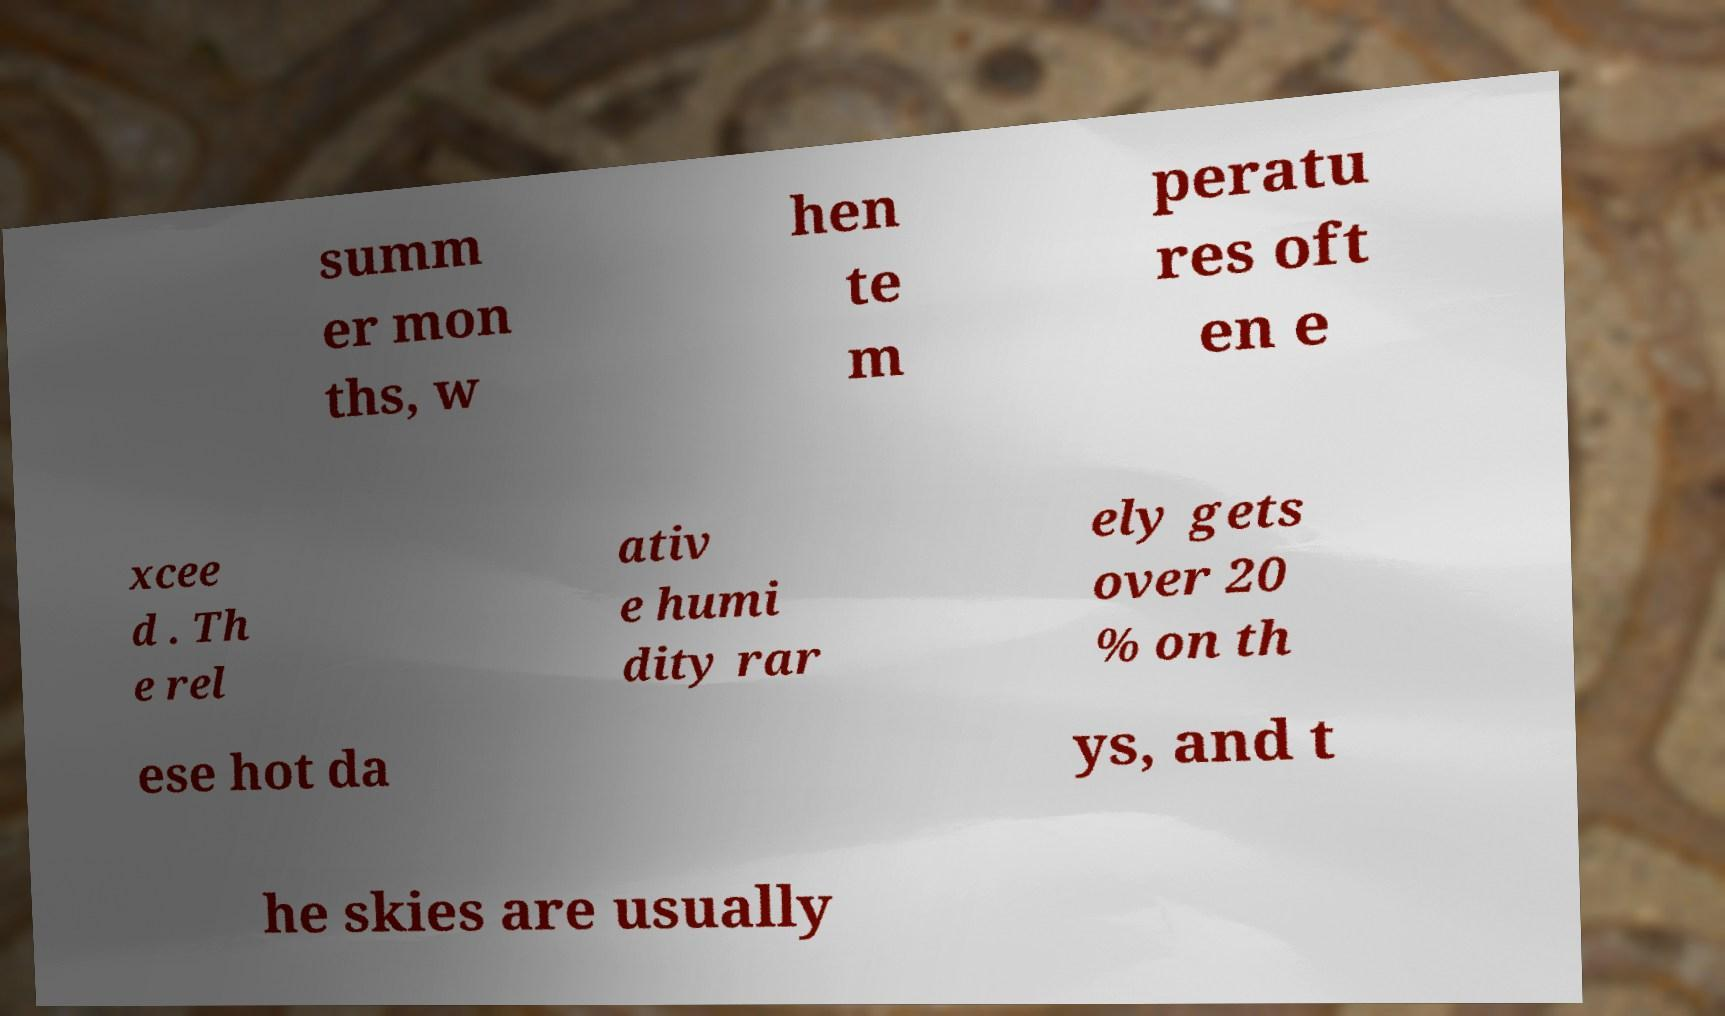Please read and relay the text visible in this image. What does it say? summ er mon ths, w hen te m peratu res oft en e xcee d . Th e rel ativ e humi dity rar ely gets over 20 % on th ese hot da ys, and t he skies are usually 